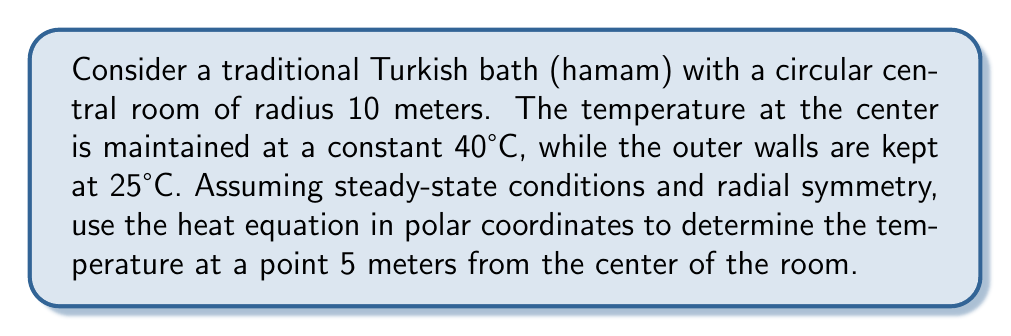Help me with this question. 1) The steady-state heat equation in polar coordinates with radial symmetry is:

   $$ \frac{1}{r} \frac{d}{dr} \left(r \frac{dT}{dr}\right) = 0 $$

2) Integrating once:

   $$ r \frac{dT}{dr} = C_1 $$

3) Integrating again:

   $$ T(r) = C_1 \ln(r) + C_2 $$

4) Apply boundary conditions:
   At $r = 0$, $T = 40°C$
   At $r = 10$, $T = 25°C$

5) Substituting $r = 10$ into the general solution:

   $$ 25 = C_1 \ln(10) + C_2 $$

6) As $r$ approaches 0, $\ln(r)$ approaches negative infinity. To avoid this, $C_1$ must be 0.

7) Therefore, $C_2 = 40$ (to satisfy $T = 40°C$ at $r = 0$)

8) The solution is thus:

   $$ T(r) = 40 - \frac{15r^2}{100} $$

9) At $r = 5$ meters:

   $$ T(5) = 40 - \frac{15(5^2)}{100} = 40 - \frac{375}{100} = 36.25°C $$
Answer: 36.25°C 